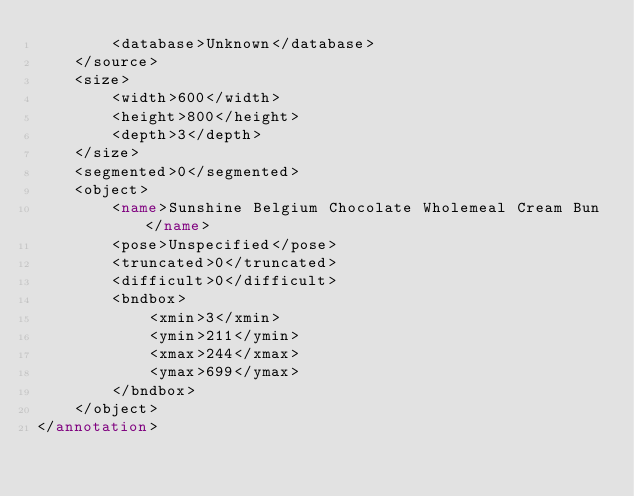Convert code to text. <code><loc_0><loc_0><loc_500><loc_500><_XML_>		<database>Unknown</database>
	</source>
	<size>
		<width>600</width>
		<height>800</height>
		<depth>3</depth>
	</size>
	<segmented>0</segmented>
	<object>
		<name>Sunshine Belgium Chocolate Wholemeal Cream Bun</name>
		<pose>Unspecified</pose>
		<truncated>0</truncated>
		<difficult>0</difficult>
		<bndbox>
			<xmin>3</xmin>
			<ymin>211</ymin>
			<xmax>244</xmax>
			<ymax>699</ymax>
		</bndbox>
	</object>
</annotation>
</code> 